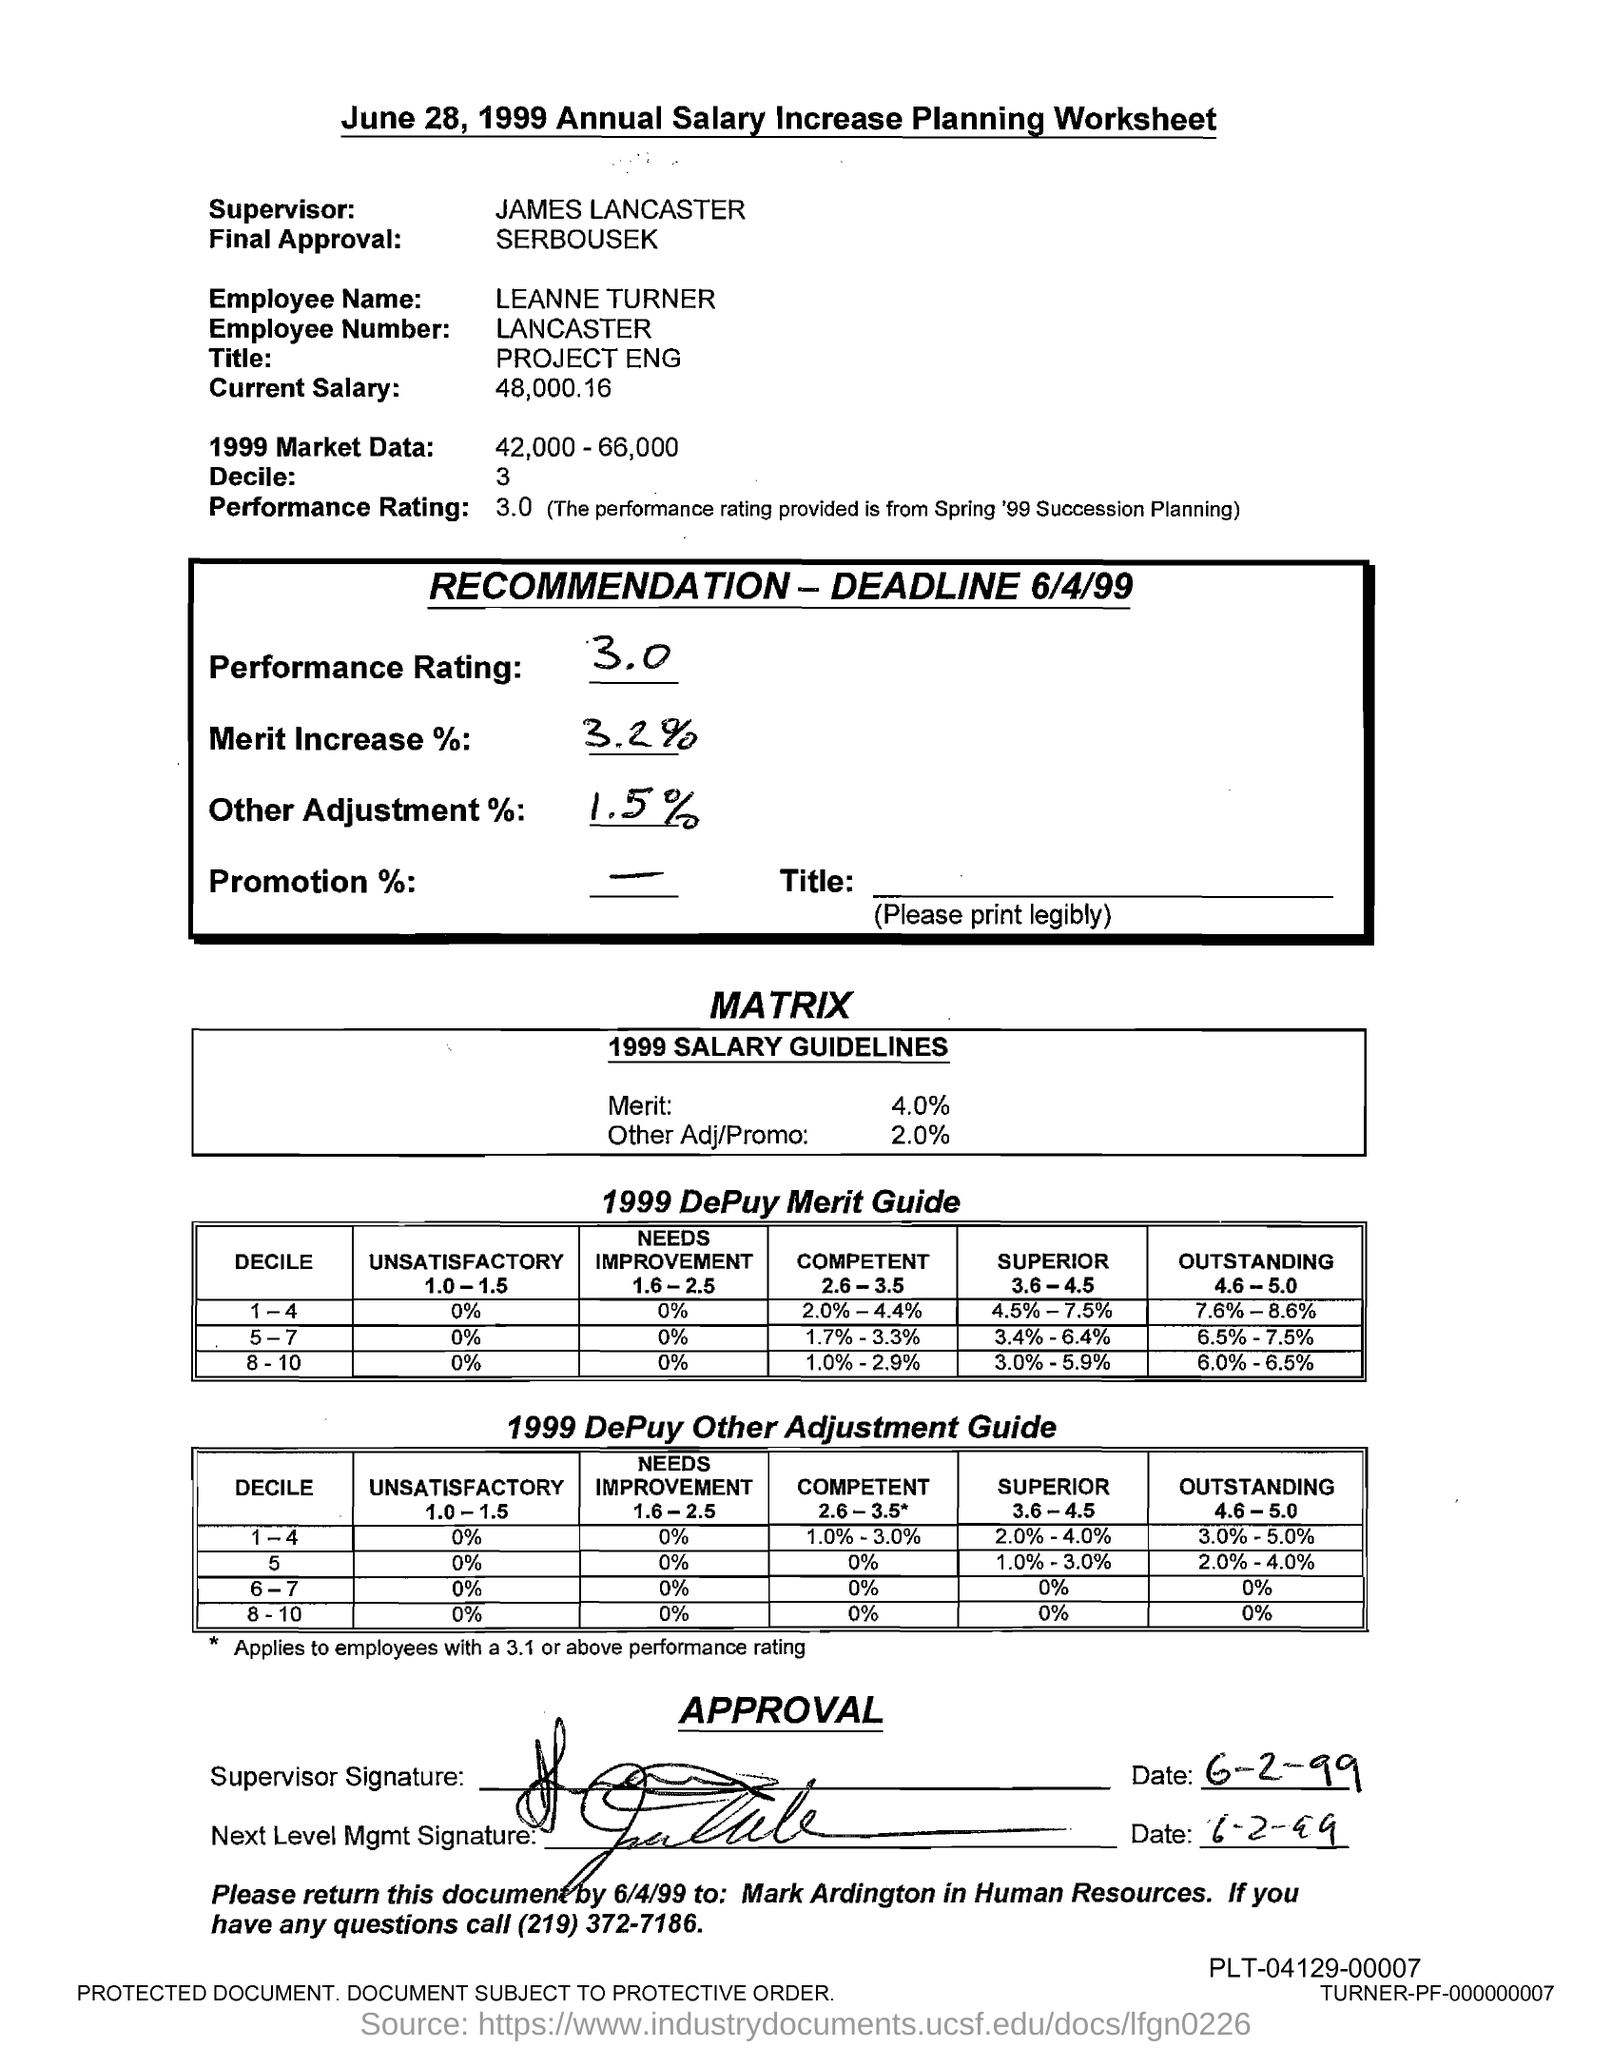Mention a couple of crucial points in this snapshot. The employee's name mentioned in the document is Leanne Turner. This is an annual salary increase planning worksheet. The current salary of Leanne Turner is 48,000.16. The supervisor mentioned in the document is James Lancaster. Leanne Turner is a project engineer. 